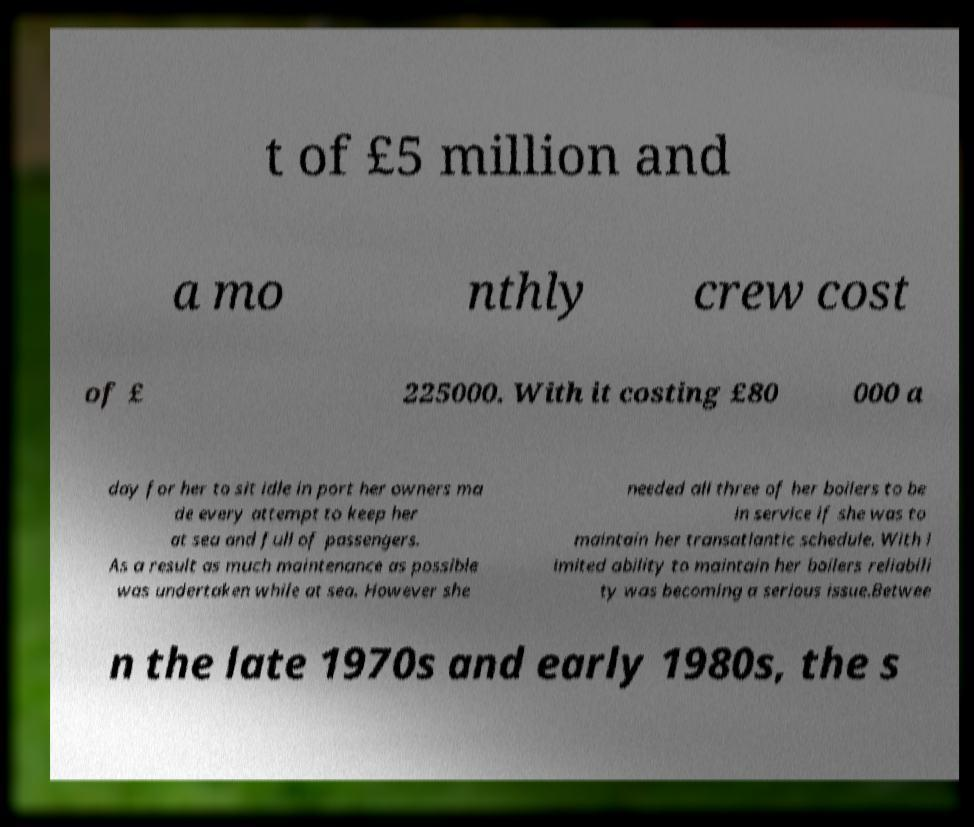Please read and relay the text visible in this image. What does it say? t of £5 million and a mo nthly crew cost of £ 225000. With it costing £80 000 a day for her to sit idle in port her owners ma de every attempt to keep her at sea and full of passengers. As a result as much maintenance as possible was undertaken while at sea. However she needed all three of her boilers to be in service if she was to maintain her transatlantic schedule. With l imited ability to maintain her boilers reliabili ty was becoming a serious issue.Betwee n the late 1970s and early 1980s, the s 